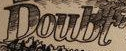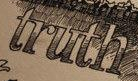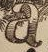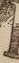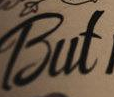What words are shown in these images in order, separated by a semicolon? Doubt; truth; a; #; But 